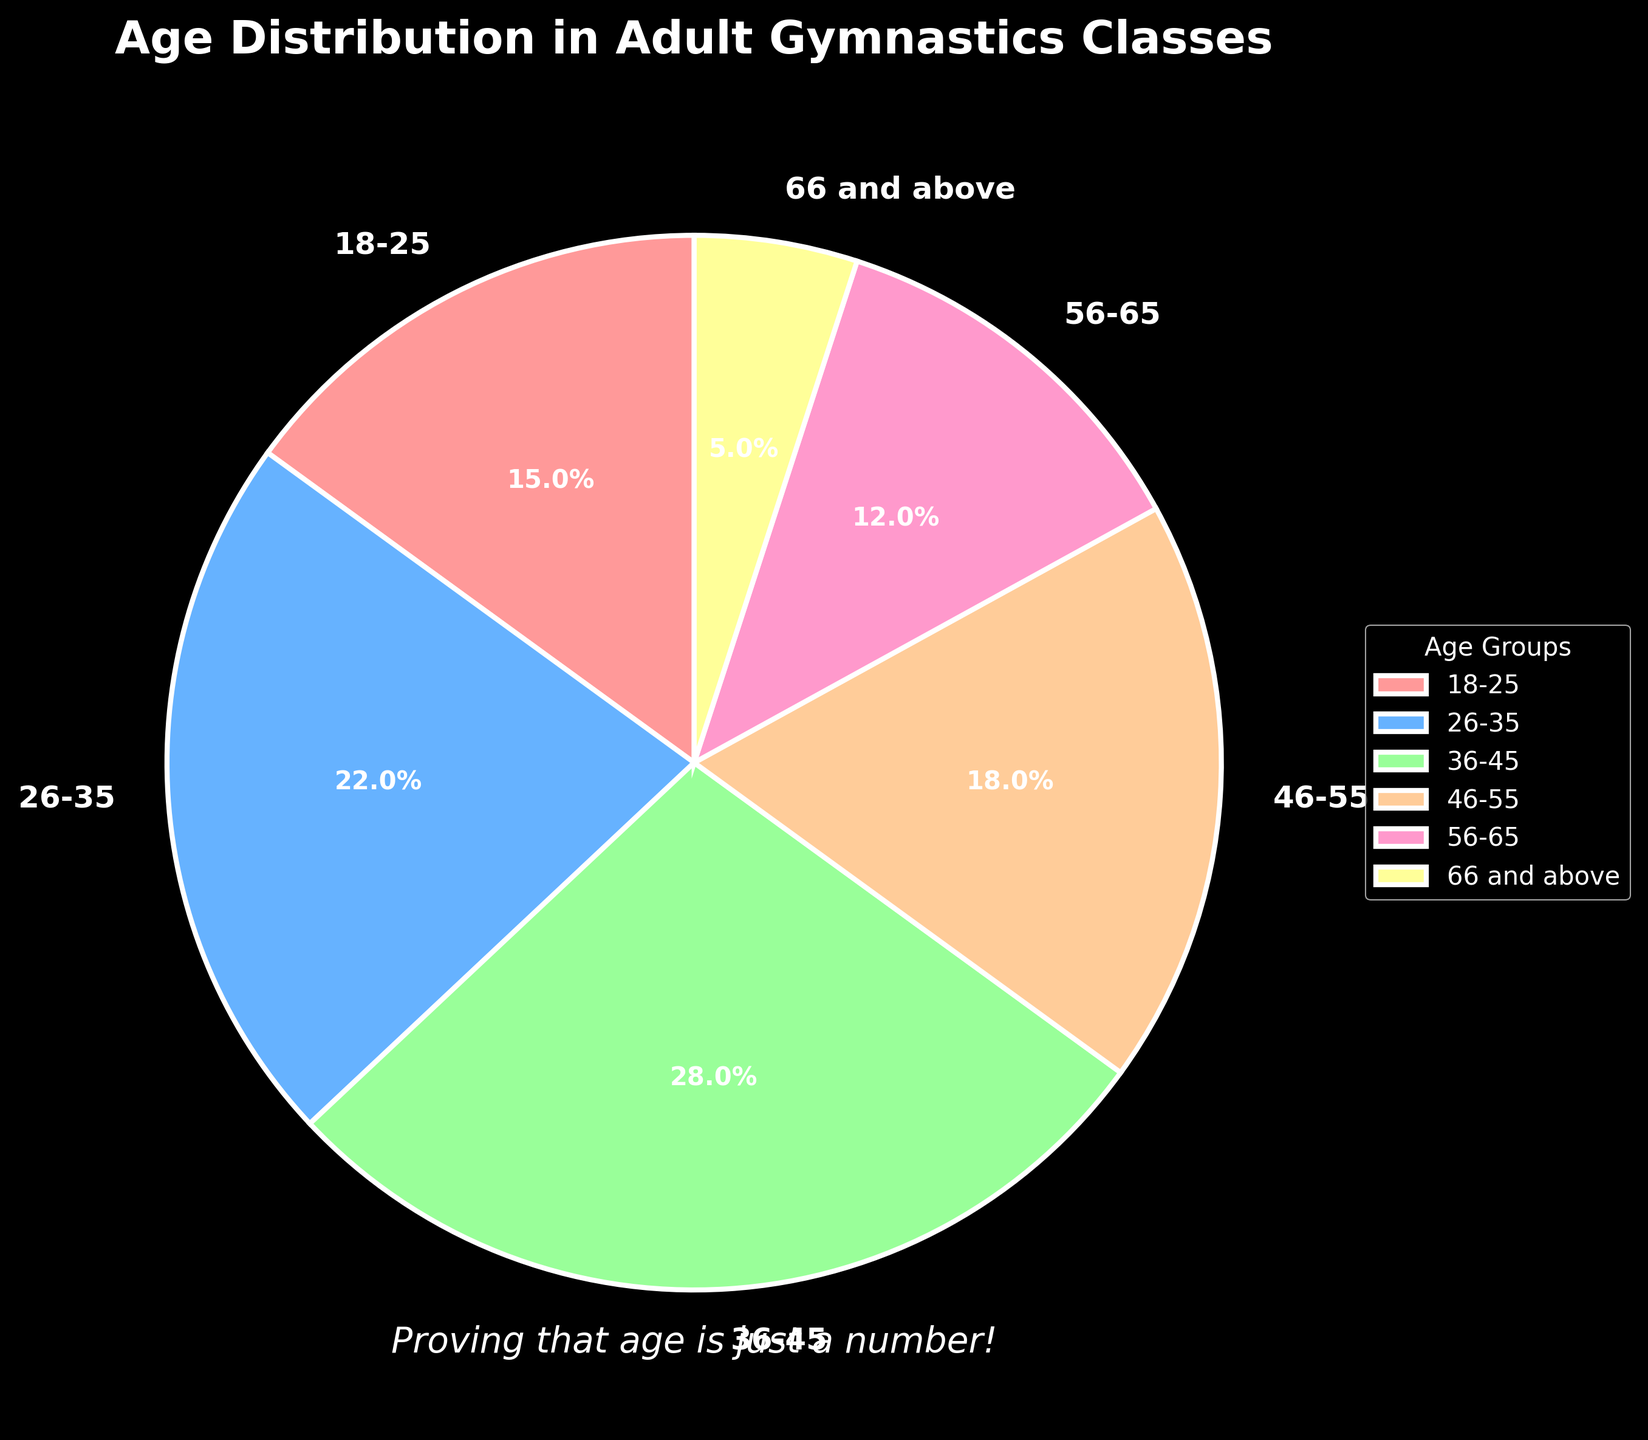Which age group has the highest percentage of participation? The chart shows six age groups with associated percentages. By comparing these, we see that the 36-45 age group has the highest percentage (28%).
Answer: 36-45 What is the combined percentage of participants aged 26-35 and 46-55? Add the percentages for the two age groups: 22% (26-35) + 18% (46-55) = 40%.
Answer: 40% How much higher is the participation percentage of the 36-45 age group compared to the 66 and above age group? Subtract the percentage of the 66 and above group from the 36-45 group: 28% - 5% = 23%.
Answer: 23% What is the total percentage of participants below the age of 36? Add the percentages for the 18-25 and 26-35 age groups: 15% (18-25) + 22% (26-35) = 37%.
Answer: 37% Which age groups have less than 20% participation individually? Identify the age groups with percentages below 20%. These are the 18-25 (15%), 56-65 (12%), and 66 and above (5%) age groups.
Answer: 18-25, 56-65, 66 and above Which color represents the 66 and above age group on the chart? Observing the chart, the 66 and above age group is represented by a light yellow color.
Answer: light yellow Is the participation rate of the 46-55 age group closer to that of the 18-25 or 56-65 age groups? Compare the differences: 18-25 (15%) to 46-55 (18%) has a difference of 3%, while 56-65 (12%) to 46-55 (18%) has a difference of 6%. Thus, the 46-55 age group's participation rate is closer to 18-25.
Answer: 18-25 What age group is represented by the blue section of the pie chart? By looking at the colors and their corresponding age group labels, the blue section represents the 26-35 age group.
Answer: 26-35 Calculate the average participation percentage across all age groups. Sum all percentages and divide by the number of age groups: (15% + 22% + 28% + 18% + 12% + 5%) / 6 = 100% / 6 ≈ 16.67%.
Answer: 16.67% How does the percentage of participants aged 56-65 compare to the percentage of participants aged 18-25? Compare the percentages directly: 12% (56-65) vs. 15% (18-25). Thus, the 56-65 age group has 3% fewer participants than the 18-25 age group.
Answer: 3% fewer 